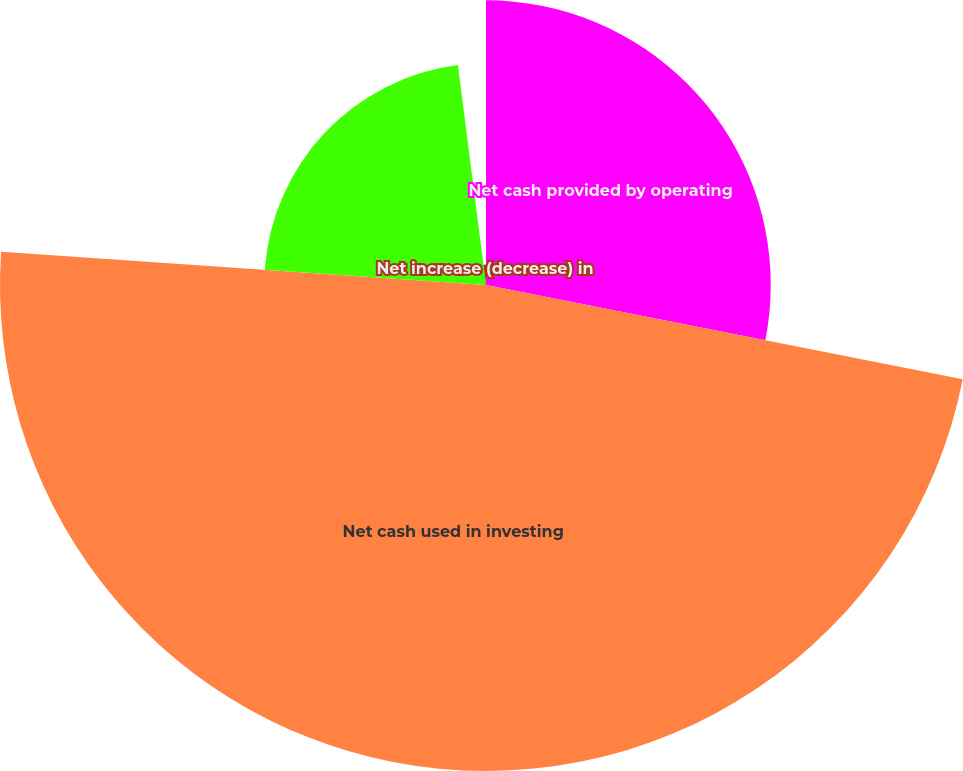Convert chart to OTSL. <chart><loc_0><loc_0><loc_500><loc_500><pie_chart><fcel>Net cash provided by operating<fcel>Net cash used in investing<fcel>Net cash provided by (used in)<fcel>Net increase (decrease) in<nl><fcel>28.11%<fcel>47.98%<fcel>21.89%<fcel>2.02%<nl></chart> 